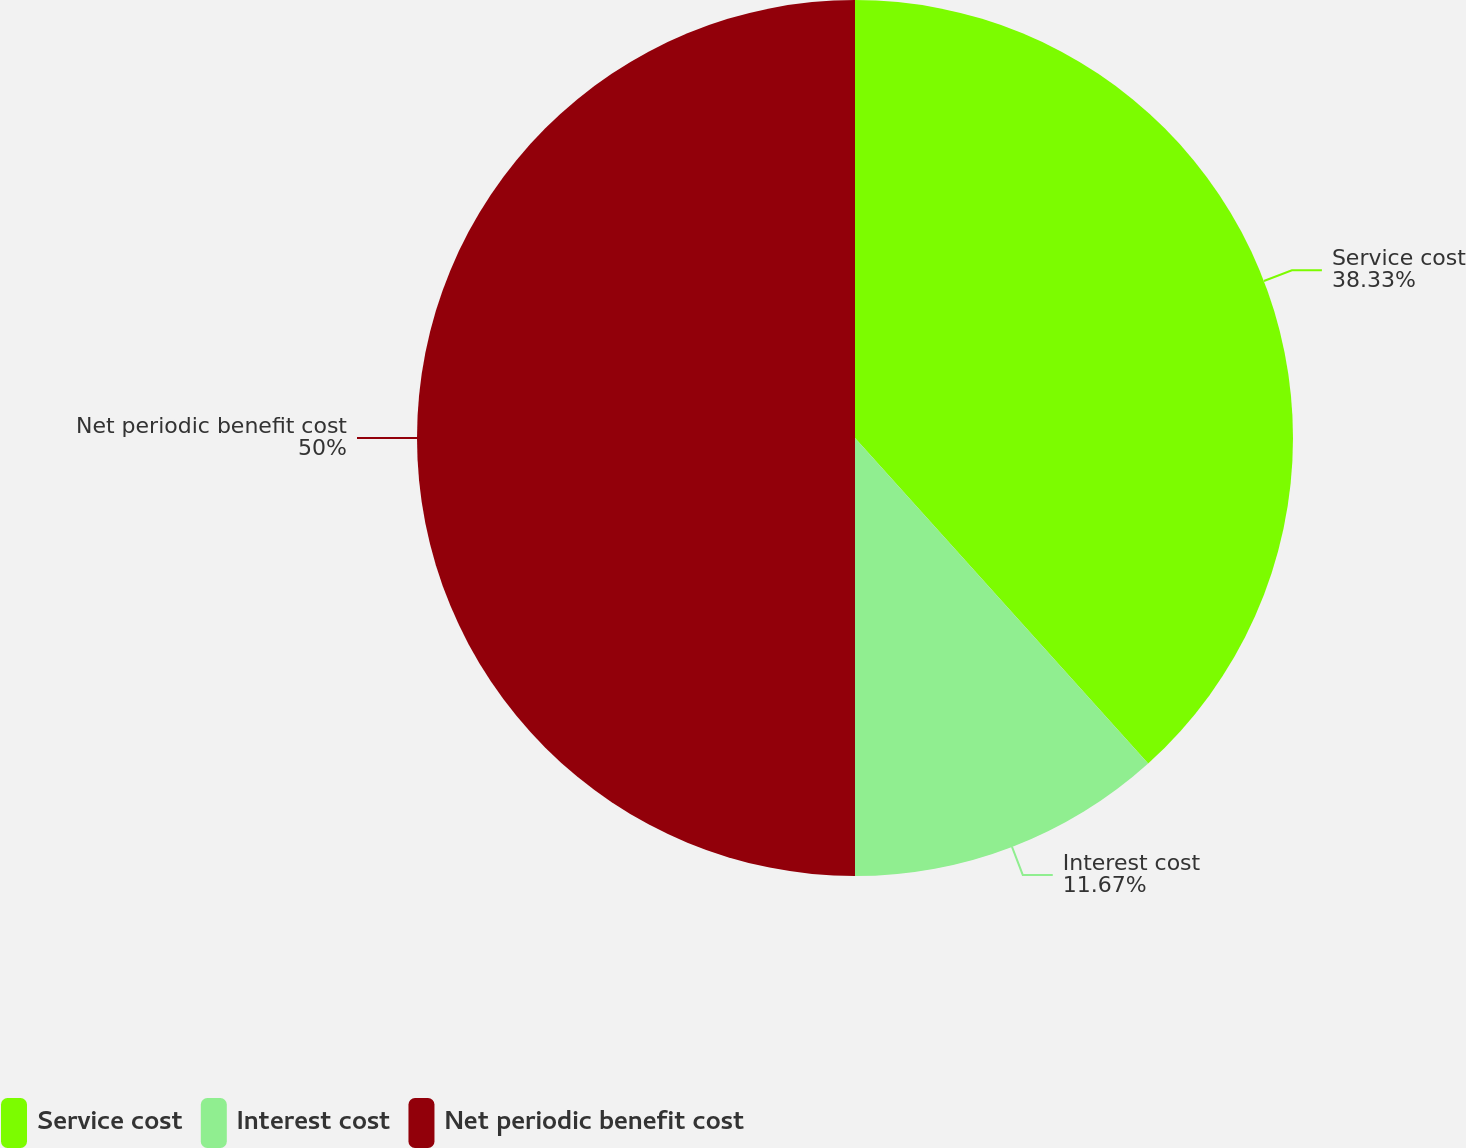<chart> <loc_0><loc_0><loc_500><loc_500><pie_chart><fcel>Service cost<fcel>Interest cost<fcel>Net periodic benefit cost<nl><fcel>38.33%<fcel>11.67%<fcel>50.0%<nl></chart> 